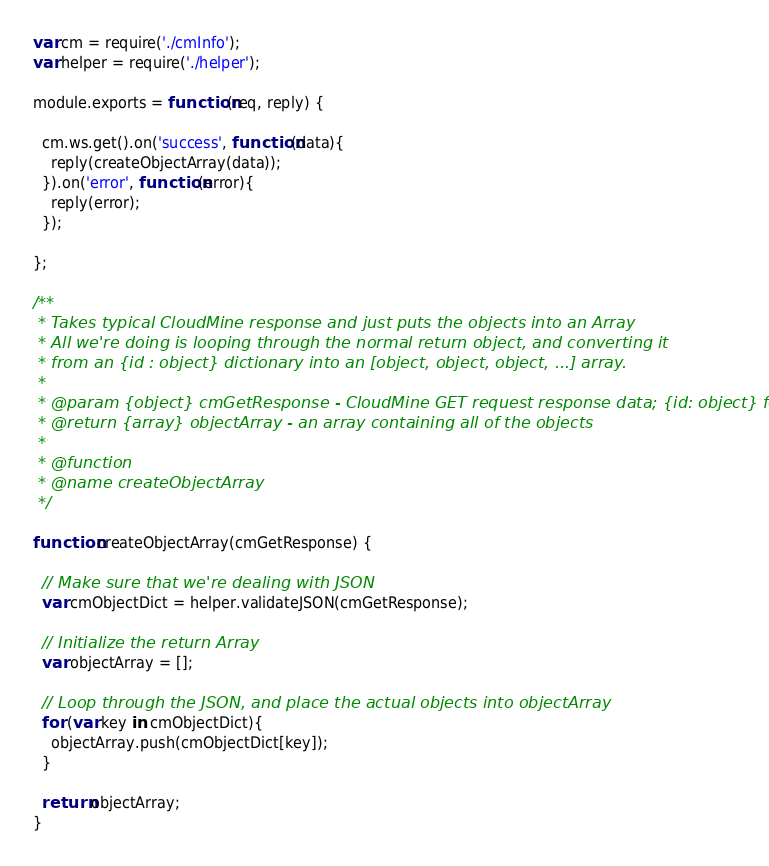<code> <loc_0><loc_0><loc_500><loc_500><_JavaScript_>var cm = require('./cmInfo');
var helper = require('./helper');

module.exports = function(req, reply) {

  cm.ws.get().on('success', function(data){
    reply(createObjectArray(data));
  }).on('error', function(error){
    reply(error);
  });

};

/**
 * Takes typical CloudMine response and just puts the objects into an Array
 * All we're doing is looping through the normal return object, and converting it
 * from an {id : object} dictionary into an [object, object, object, ...] array.
 *
 * @param {object} cmGetResponse - CloudMine GET request response data; {id: object} format
 * @return {array} objectArray - an array containing all of the objects
 *
 * @function
 * @name createObjectArray
 */

function createObjectArray(cmGetResponse) {

  // Make sure that we're dealing with JSON
  var cmObjectDict = helper.validateJSON(cmGetResponse);

  // Initialize the return Array
  var objectArray = [];

  // Loop through the JSON, and place the actual objects into objectArray
  for (var key in cmObjectDict){
    objectArray.push(cmObjectDict[key]);
  }

  return objectArray;
}
</code> 